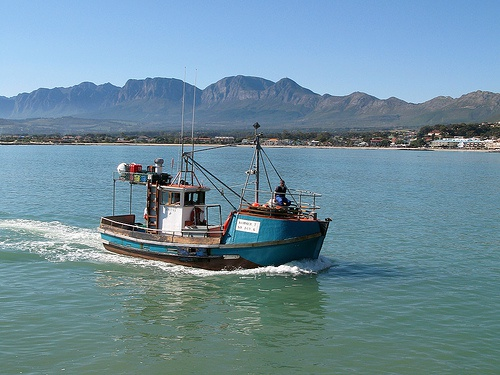Describe the objects in this image and their specific colors. I can see boat in lightblue, black, gray, and lightgray tones and people in lightblue, black, gray, and navy tones in this image. 